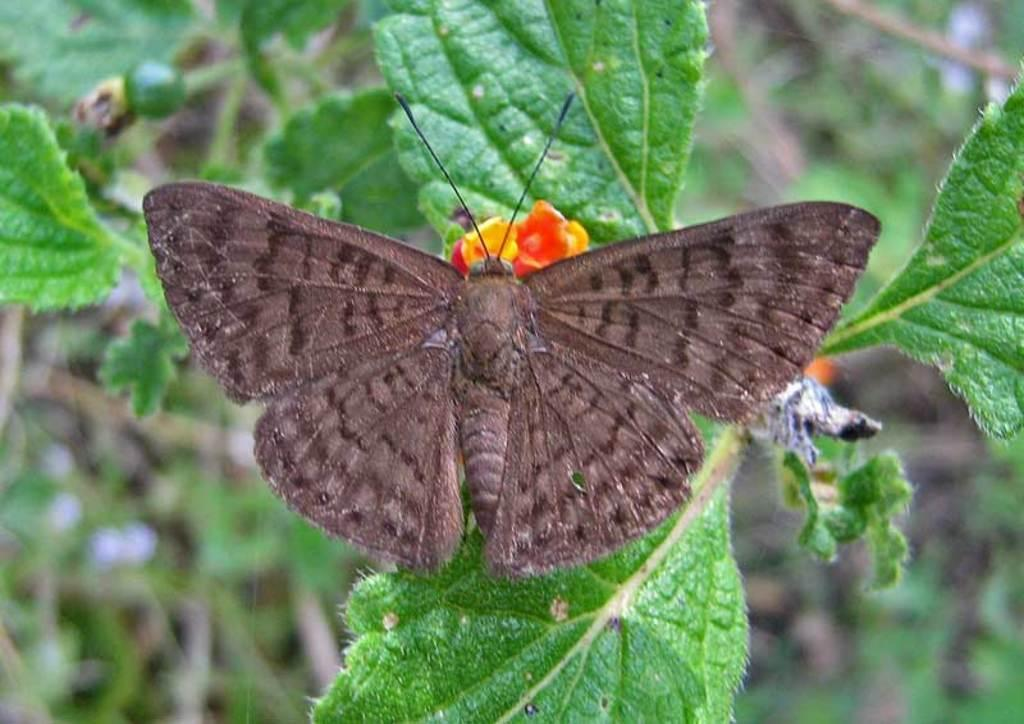What is the main subject of the image? There is a butterfly on a flower in the image. What other elements are present in the image? There are plants in the image. How would you describe the background of the image? The background of the image is blurred. What type of pie is being served to the donkey in the image? There is no donkey or pie present in the image; it features a butterfly on a flower with plants in the background. 